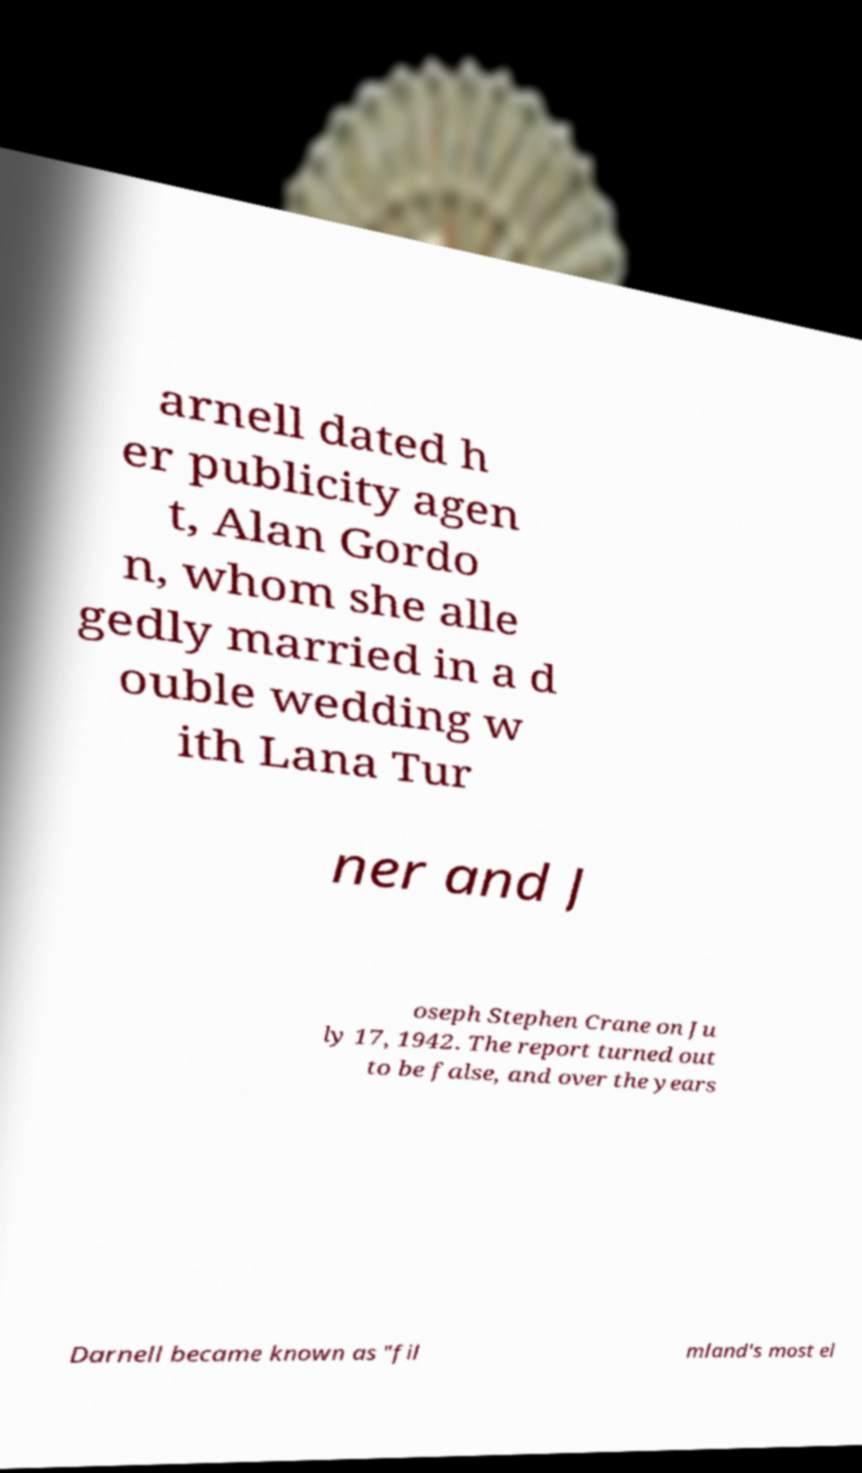Please read and relay the text visible in this image. What does it say? arnell dated h er publicity agen t, Alan Gordo n, whom she alle gedly married in a d ouble wedding w ith Lana Tur ner and J oseph Stephen Crane on Ju ly 17, 1942. The report turned out to be false, and over the years Darnell became known as "fil mland's most el 